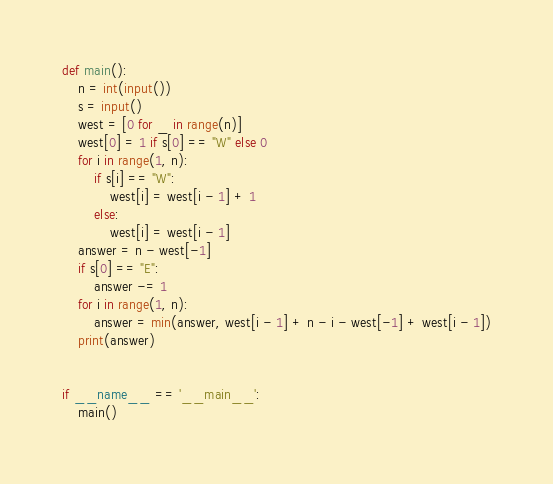Convert code to text. <code><loc_0><loc_0><loc_500><loc_500><_Python_>def main():
    n = int(input())
    s = input()
    west = [0 for _ in range(n)]
    west[0] = 1 if s[0] == "W" else 0
    for i in range(1, n):
        if s[i] == "W":
            west[i] = west[i - 1] + 1
        else:
            west[i] = west[i - 1]
    answer = n - west[-1]
    if s[0] == "E":
        answer -= 1
    for i in range(1, n):
        answer = min(answer, west[i - 1] + n - i - west[-1] + west[i - 1])
    print(answer)


if __name__ == '__main__':
    main()

</code> 